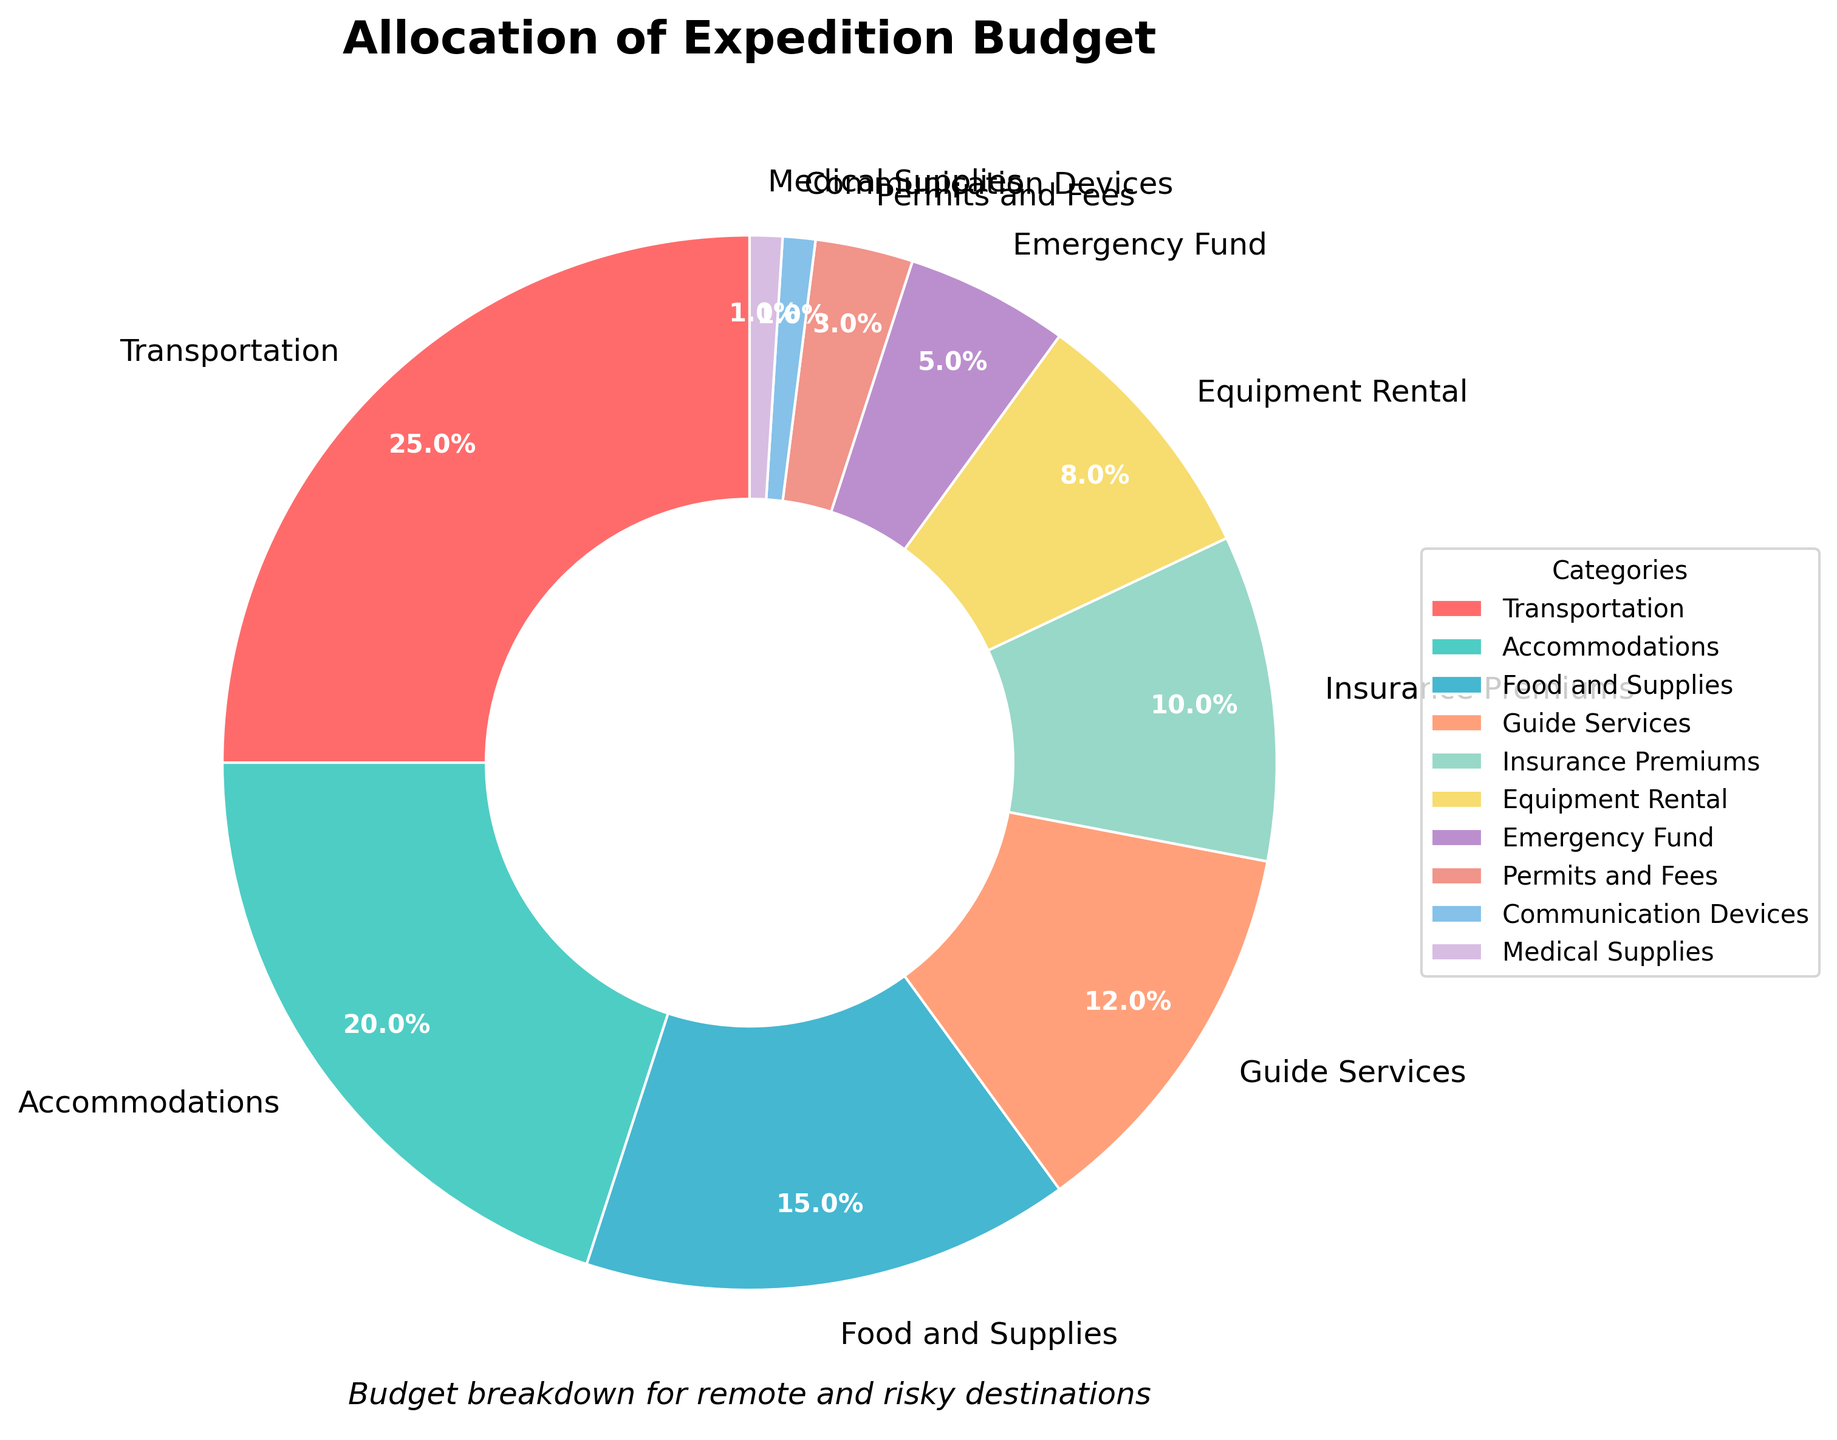What percentage of the budget is allocated to both Guide Services and Equipment Rental combined? The chart shows the percentages for Guide Services and Equipment Rental as 12% and 8%, respectively. Adding these together gives 12% + 8% = 20%.
Answer: 20% Is the budget for Accommodations greater than that for Food and Supplies, and if so, by how much? The chart shows that Accommodations have a budget of 20% and Food and Supplies have a budget of 15%. The difference is 20% - 15% = 5%.
Answer: Yes, by 5% Which category has the lowest budget allocation, and what is its percentage? The smallest slice in the pie chart corresponds to Communication Devices and Medical Supplies, both of which have a 1% allocation.
Answer: Communication Devices and Medical Supplies, 1% How does the budget allocation for Insurance Premiums compare to the budget for Transportation? The chart shows Insurance Premiums at 10% and Transportation at 25%. Therefore, Transportation has a higher allocation.
Answer: Transportation is higher What is the total budget allocation for Emergency Fund, Permits and Fees, and Communication Devices combined? According to the chart, Emergency Fund is 5%, Permits and Fees is 3%, and Communication Devices is 1%. Adding these gives 5% + 3% + 1% = 9%.
Answer: 9% Which category has the second-highest budget allocation? From the chart, after Transportation (25%), the next highest allocation is Accommodations at 20%.
Answer: Accommodations What is the difference in budget allocation between Food and Supplies and Equipment Rental? The pie chart allocates 15% to Food and Supplies and 8% to Equipment Rental. The difference is 15% - 8% = 7%.
Answer: 7% Which two categories have the closest budget allocations, and what are their percentages? Guide Services are 12% and Insurance Premiums are 10%, giving a difference of just 2 percentage points.
Answer: Guide Services (12%) and Insurance Premiums (10%) What is the combined budget allocation for categories that have an allocation of less than 5%? The categories with less than 5% are Permits and Fees (3%), Communication Devices (1%), and Medical Supplies (1%). Summing these gives 3% + 1% + 1% = 5%.
Answer: 5% If the budget for Transportation were to be reduced by 5% and this was added to the budget for Food and Supplies, what would the new percentages be? Transportation is currently 25%; reducing it by 5% gives 20%. Food and Supplies is currently 15%; adding 5% gives 20%. New percentages: Transportation 20%, Food and Supplies 20%.
Answer: Transportation 20%, Food and Supplies 20% 